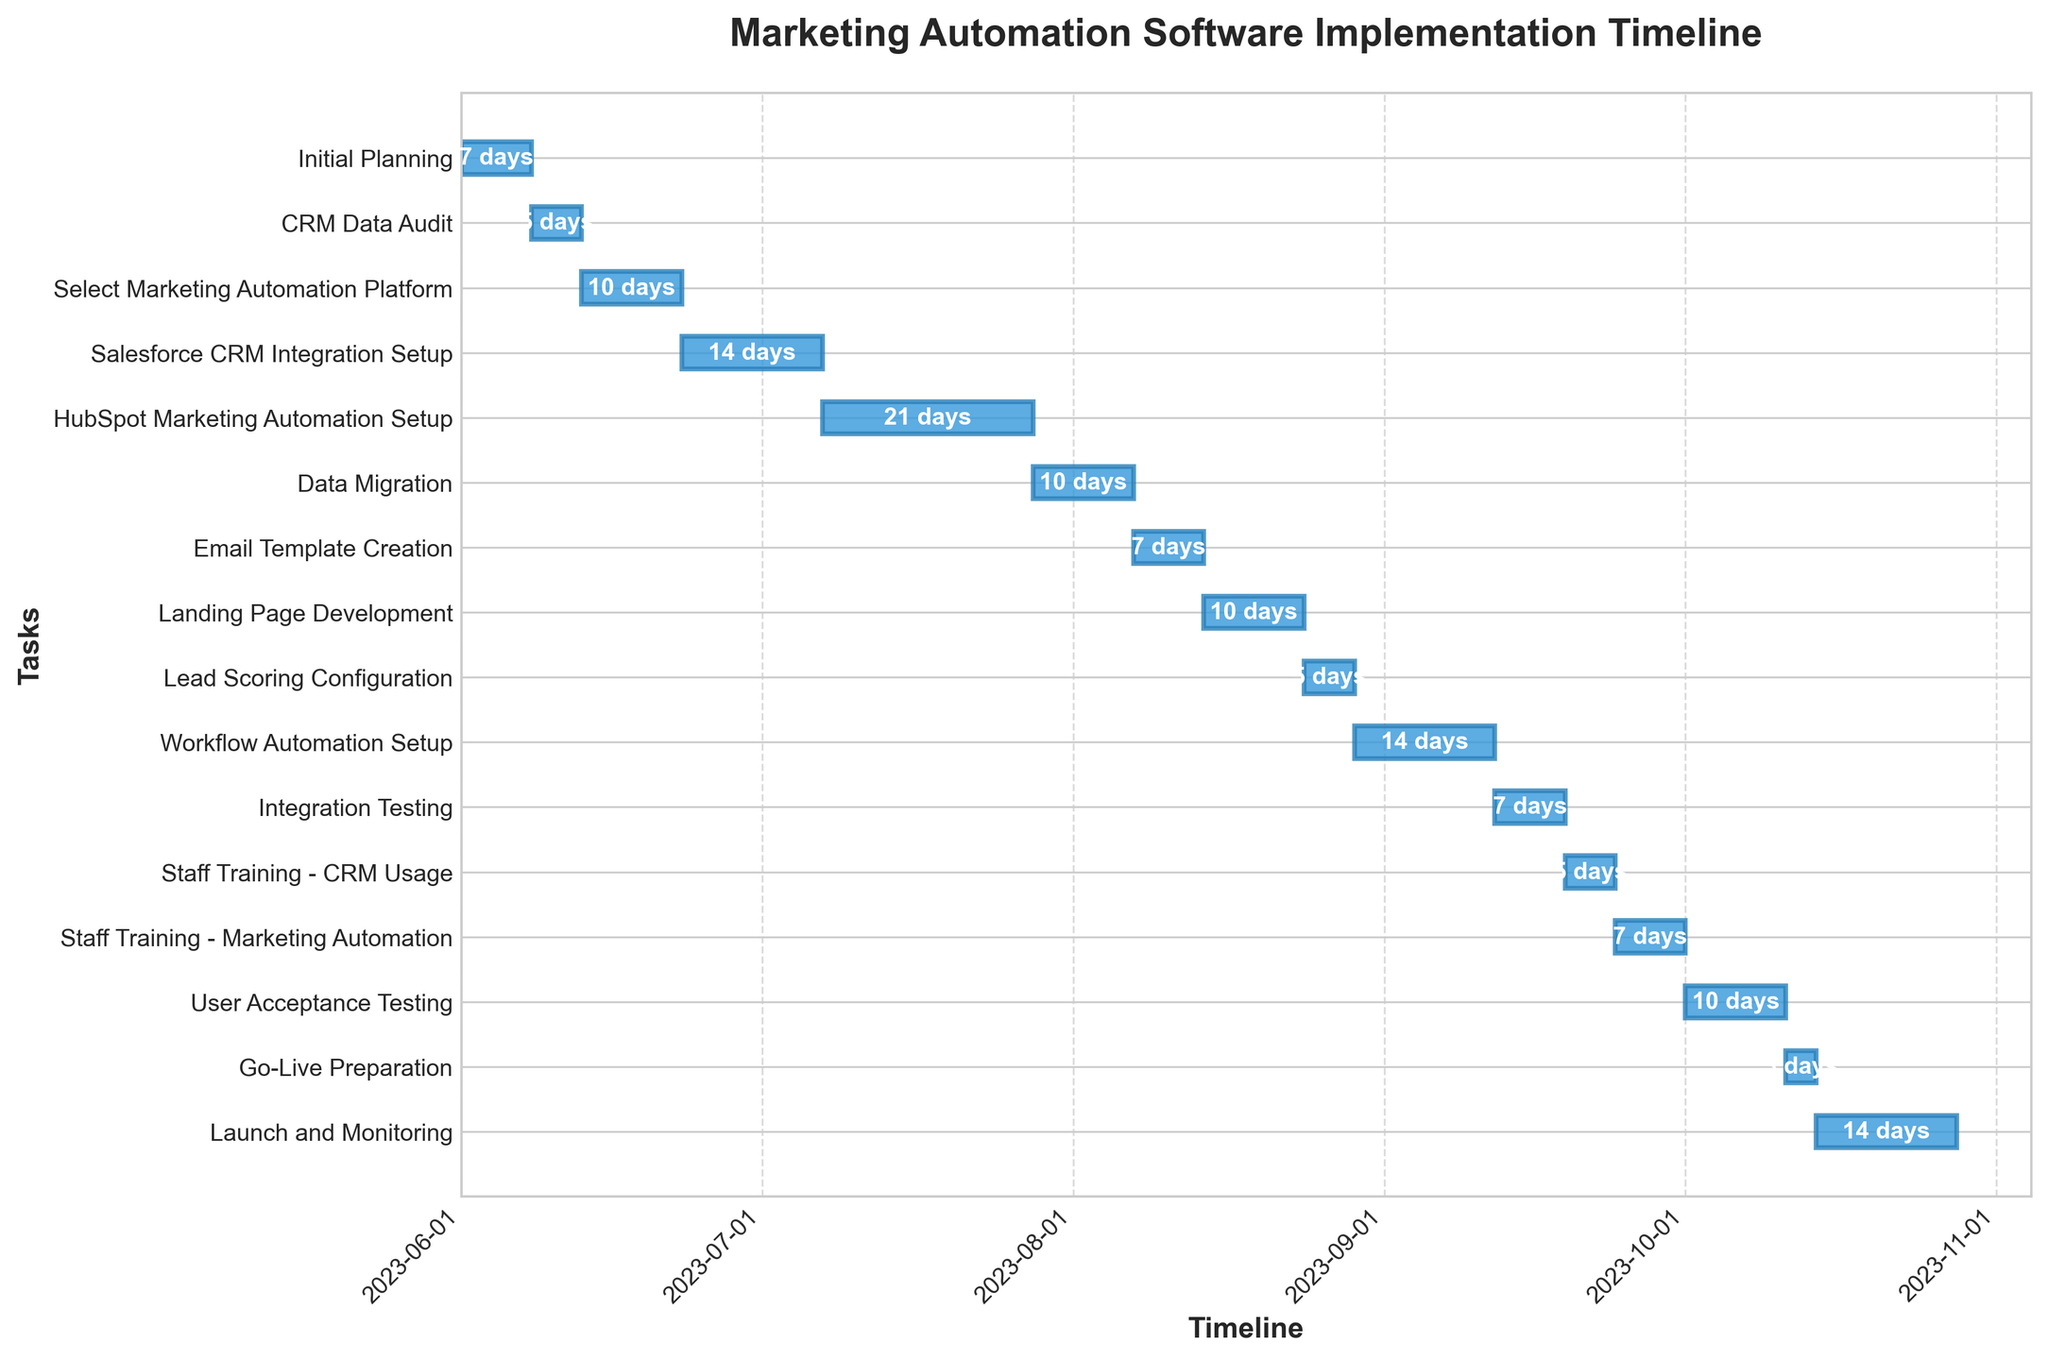How long does the "Workflow Automation Setup" task take? The figure shows the duration of each task. Locate "Workflow Automation Setup" and observe the number of days displayed on the bar.
Answer: 14 days When does the "HubSpot Marketing Automation Setup" start? The figure displays start dates for each task. Find "HubSpot Marketing Automation Setup" and read the start date on the timeline axis.
Answer: 2023-07-07 Which task takes the longest duration to complete? Compare the lengths of each bar representing task durations. Identify the bar that extends the farthest to the right.
Answer: HubSpot Marketing Automation Setup How many tasks are there in total in the implementation timeline? Count the number of horizontal bars in the Gantt chart that represent different tasks.
Answer: 16 Which tasks are scheduled to start in the month of August? Identify tasks by checking their start dates with the timeline axis and list those starting between 2023-08-01 and 2023-08-31.
Answer: Email Template Creation, Landing Page Development, Lead Scoring Configuration, Workflow Automation Setup What is the total duration of the "Integration Testing" and "User Acceptance Testing" combined? Find the durations of both "Integration Testing" and "User Acceptance Testing" and sum them up.
Answer: 17 days Which task immediately follows the "CRM Data Audit"? Check the end date of "CRM Data Audit" and find which task starts right after it.
Answer: Select Marketing Automation Platform How long after the "Initial Planning" does the "CRM Data Audit" begin? Note the end date of "Initial Planning" and the start date of "CRM Data Audit" and calculate the days between them.
Answer: 0 days Which tasks overlap in their duration with the "Salesforce CRM Integration Setup"? Identify the start and end date range of "Salesforce CRM Integration Setup" and see which tasks' durations fall into this range.
Answer: HubSpot Marketing Automation Setup, Data Migration Does the "Launch and Monitoring" task end before November 2023? Observe the end date of "Launch and Monitoring" and check if it falls before 2023-11-01 on the timeline axis.
Answer: Yes 